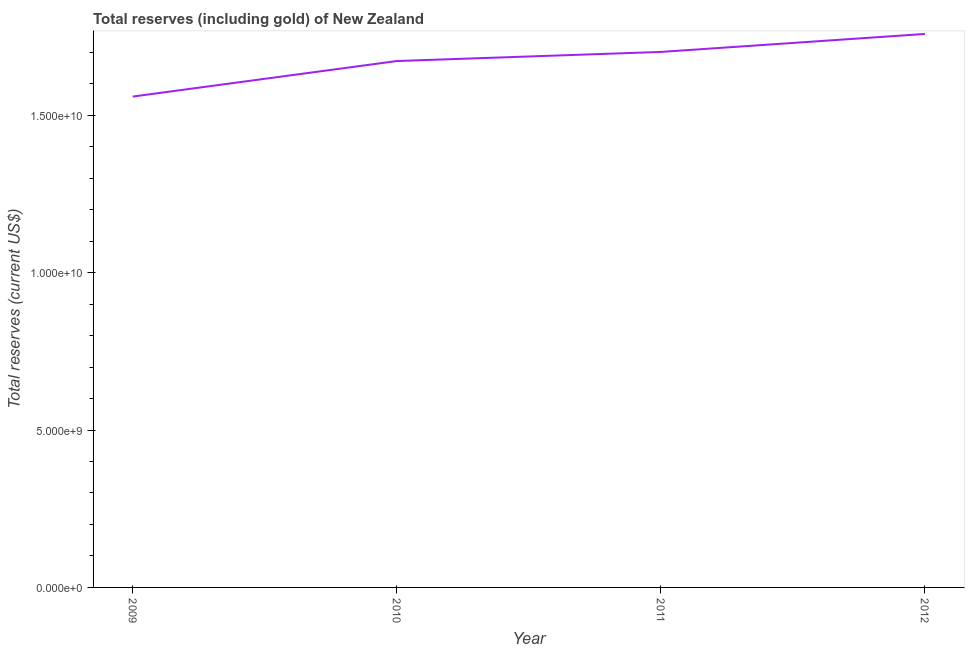What is the total reserves (including gold) in 2009?
Make the answer very short. 1.56e+1. Across all years, what is the maximum total reserves (including gold)?
Your answer should be compact. 1.76e+1. Across all years, what is the minimum total reserves (including gold)?
Your answer should be very brief. 1.56e+1. What is the sum of the total reserves (including gold)?
Provide a short and direct response. 6.69e+1. What is the difference between the total reserves (including gold) in 2011 and 2012?
Offer a terse response. -5.71e+08. What is the average total reserves (including gold) per year?
Your response must be concise. 1.67e+1. What is the median total reserves (including gold)?
Provide a succinct answer. 1.69e+1. Do a majority of the years between 2010 and 2012 (inclusive) have total reserves (including gold) greater than 16000000000 US$?
Provide a succinct answer. Yes. What is the ratio of the total reserves (including gold) in 2009 to that in 2011?
Keep it short and to the point. 0.92. Is the difference between the total reserves (including gold) in 2009 and 2012 greater than the difference between any two years?
Provide a short and direct response. Yes. What is the difference between the highest and the second highest total reserves (including gold)?
Your answer should be compact. 5.71e+08. Is the sum of the total reserves (including gold) in 2009 and 2011 greater than the maximum total reserves (including gold) across all years?
Make the answer very short. Yes. What is the difference between the highest and the lowest total reserves (including gold)?
Offer a terse response. 1.99e+09. How many lines are there?
Your answer should be very brief. 1. How many years are there in the graph?
Make the answer very short. 4. What is the difference between two consecutive major ticks on the Y-axis?
Your answer should be compact. 5.00e+09. Are the values on the major ticks of Y-axis written in scientific E-notation?
Keep it short and to the point. Yes. Does the graph contain any zero values?
Offer a very short reply. No. Does the graph contain grids?
Your answer should be compact. No. What is the title of the graph?
Provide a short and direct response. Total reserves (including gold) of New Zealand. What is the label or title of the Y-axis?
Ensure brevity in your answer.  Total reserves (current US$). What is the Total reserves (current US$) in 2009?
Offer a very short reply. 1.56e+1. What is the Total reserves (current US$) in 2010?
Ensure brevity in your answer.  1.67e+1. What is the Total reserves (current US$) in 2011?
Give a very brief answer. 1.70e+1. What is the Total reserves (current US$) of 2012?
Your answer should be very brief. 1.76e+1. What is the difference between the Total reserves (current US$) in 2009 and 2010?
Your answer should be very brief. -1.13e+09. What is the difference between the Total reserves (current US$) in 2009 and 2011?
Offer a terse response. -1.42e+09. What is the difference between the Total reserves (current US$) in 2009 and 2012?
Keep it short and to the point. -1.99e+09. What is the difference between the Total reserves (current US$) in 2010 and 2011?
Offer a very short reply. -2.89e+08. What is the difference between the Total reserves (current US$) in 2010 and 2012?
Offer a very short reply. -8.60e+08. What is the difference between the Total reserves (current US$) in 2011 and 2012?
Keep it short and to the point. -5.71e+08. What is the ratio of the Total reserves (current US$) in 2009 to that in 2010?
Provide a succinct answer. 0.93. What is the ratio of the Total reserves (current US$) in 2009 to that in 2011?
Your answer should be compact. 0.92. What is the ratio of the Total reserves (current US$) in 2009 to that in 2012?
Offer a very short reply. 0.89. What is the ratio of the Total reserves (current US$) in 2010 to that in 2012?
Provide a short and direct response. 0.95. 